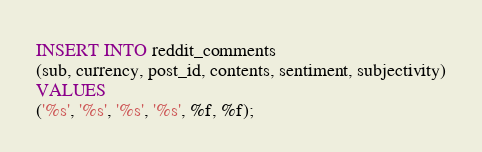Convert code to text. <code><loc_0><loc_0><loc_500><loc_500><_SQL_>INSERT INTO reddit_comments
(sub, currency, post_id, contents, sentiment, subjectivity)
VALUES
('%s', '%s', '%s', '%s', %f, %f);
</code> 